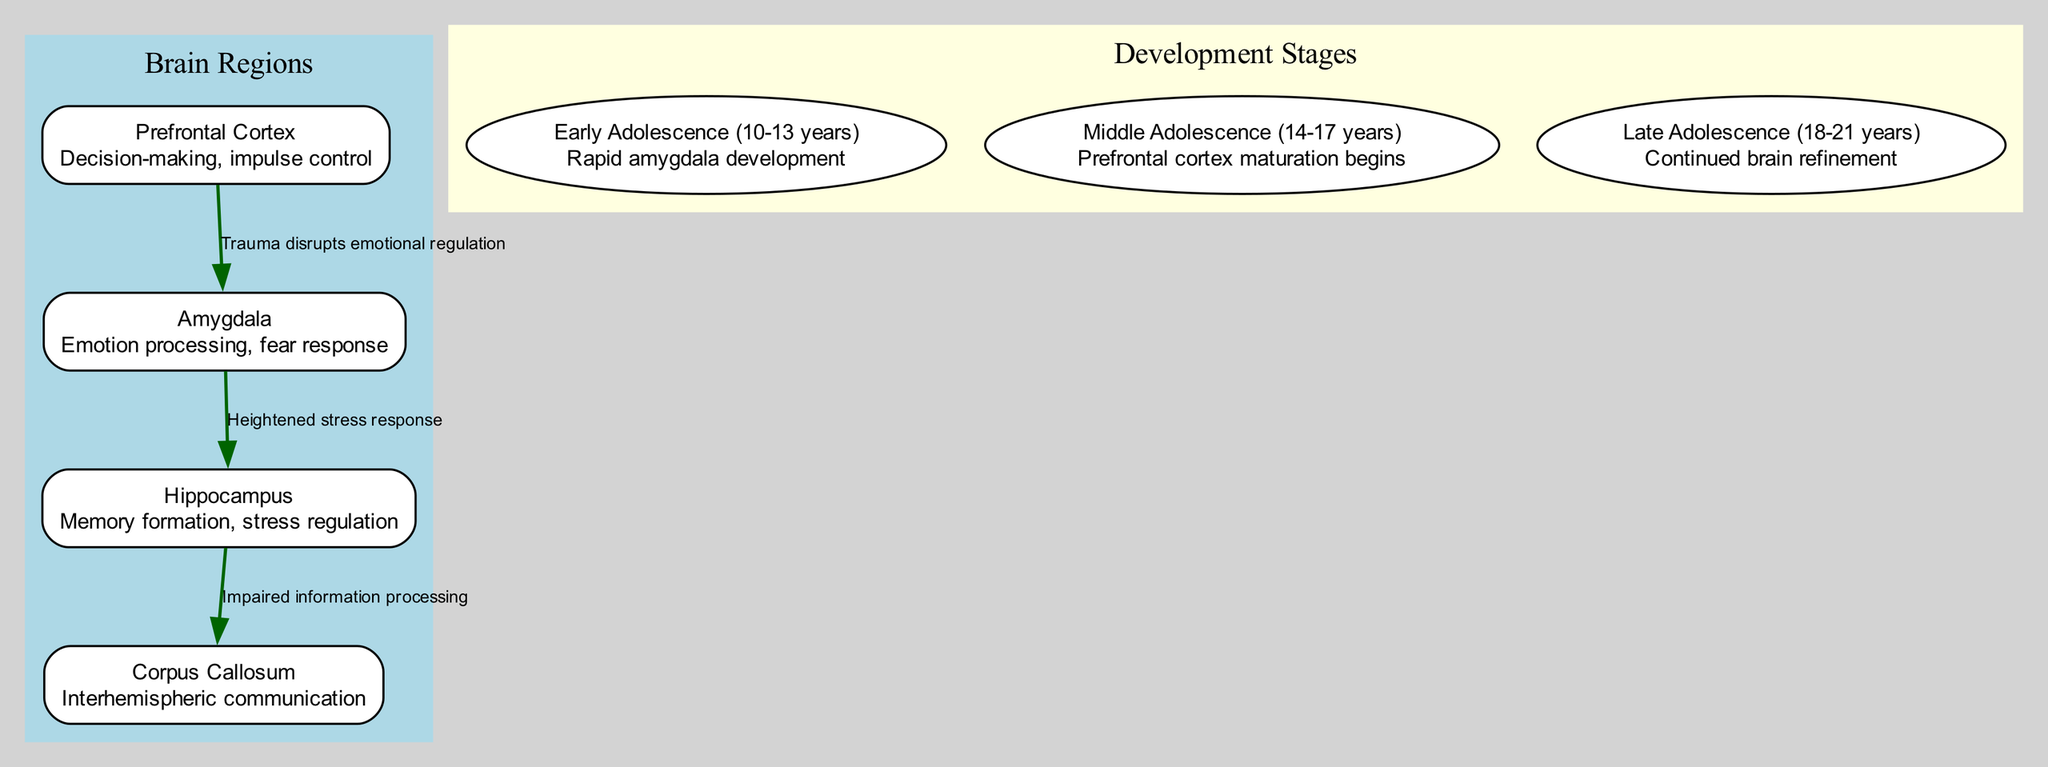What are the four key regions of the brain depicted in the diagram? The nodes in the diagram represent different regions of the brain, which are the Prefrontal Cortex, Amygdala, Hippocampus, and Corpus Callosum.
Answer: Prefrontal Cortex, Amygdala, Hippocampus, Corpus Callosum What is the main function of the Amygdala according to the diagram? The description associated with the Amygdala node specifies that its function is related to emotion processing and fear response.
Answer: Emotion processing, fear response How many edges are present in the diagram? The diagram shows three edges connecting the nodes, illustrating the relationships between the brain regions impacted by trauma.
Answer: Three Which brain region is primarily developed during early adolescence? The diagram notes that during Early Adolescence (10-13 years), the Amygdala experiences rapid development, emphasizing its importance during this stage.
Answer: Amygdala What relationship is indicated between the Prefrontal Cortex and the Amygdala? The diagram denotes an edge between the Prefrontal Cortex and the Amygdala with the label "Trauma disrupts emotional regulation," indicating a direct impact of trauma on emotional control.
Answer: Trauma disrupts emotional regulation During which stage does prefrontal cortex maturation begin? The diagram specifies that prefrontal cortex maturation begins during the Middle Adolescence stage (14-17 years).
Answer: Middle Adolescence (14-17 years) What impact does trauma have on the Hippocampus according to the diagram's flow? Analyzing the edges, it shows that trauma leads to heightened stress response in the Amygdala, which then causes impaired information processing in the Hippocampus.
Answer: Impaired information processing What is the significance of the Corpus Callosum in relation to trauma? The diagram indicates that the edges suggest information processing is impaired due to trauma effects propagating from both the Amygdala and the Hippocampus to the Corpus Callosum.
Answer: Impaired information processing How does the diagram visually represent the progression of brain development stages? The diagram uses labeled ellipses to illustrate the three stages of brain development: Early Adolescence, Middle Adolescence, and Late Adolescence, highlighting the timing of various developmental milestones.
Answer: Early Adolescence, Middle Adolescence, Late Adolescence 